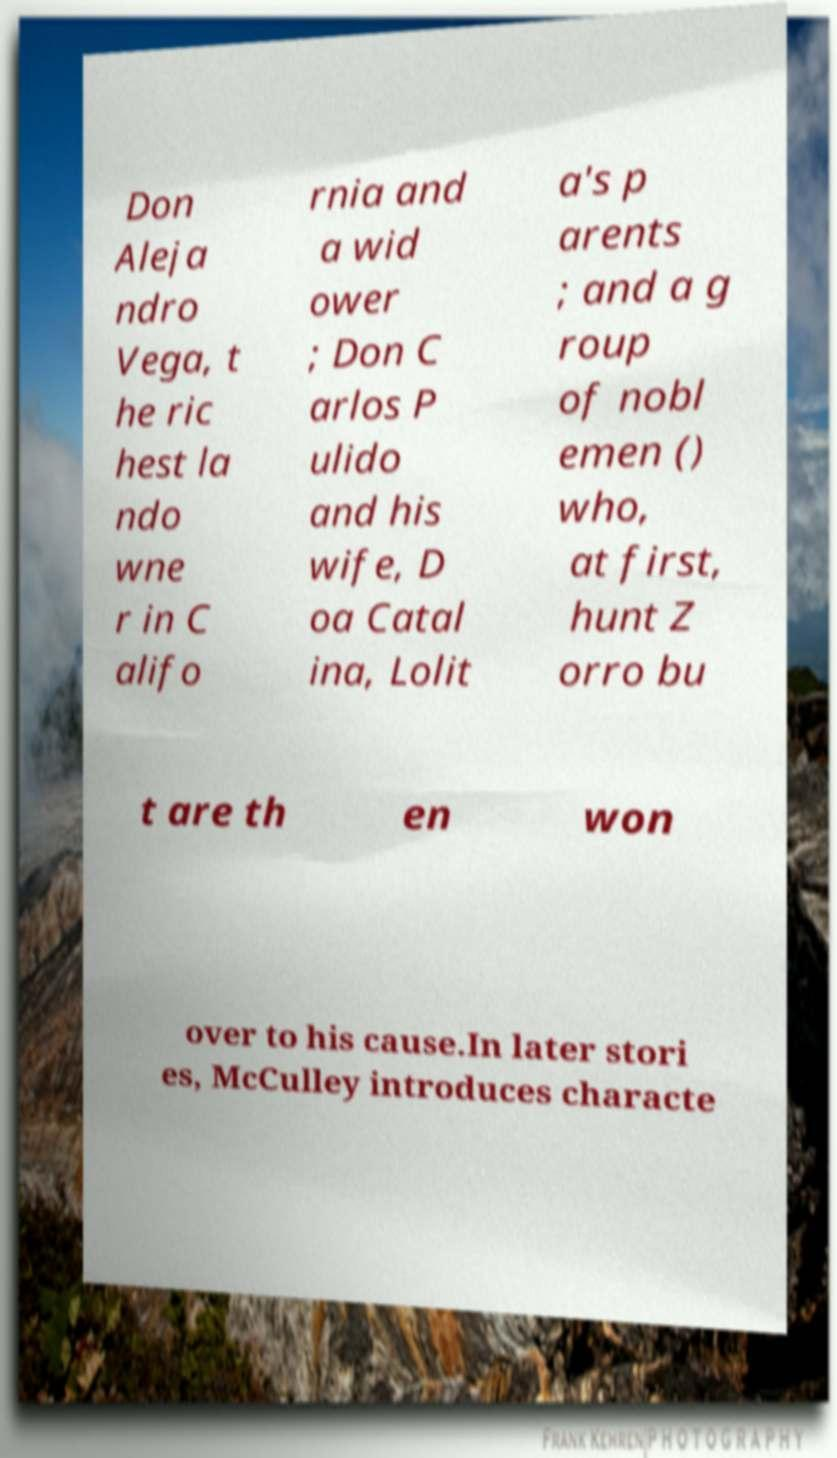Could you assist in decoding the text presented in this image and type it out clearly? Don Aleja ndro Vega, t he ric hest la ndo wne r in C alifo rnia and a wid ower ; Don C arlos P ulido and his wife, D oa Catal ina, Lolit a's p arents ; and a g roup of nobl emen () who, at first, hunt Z orro bu t are th en won over to his cause.In later stori es, McCulley introduces characte 